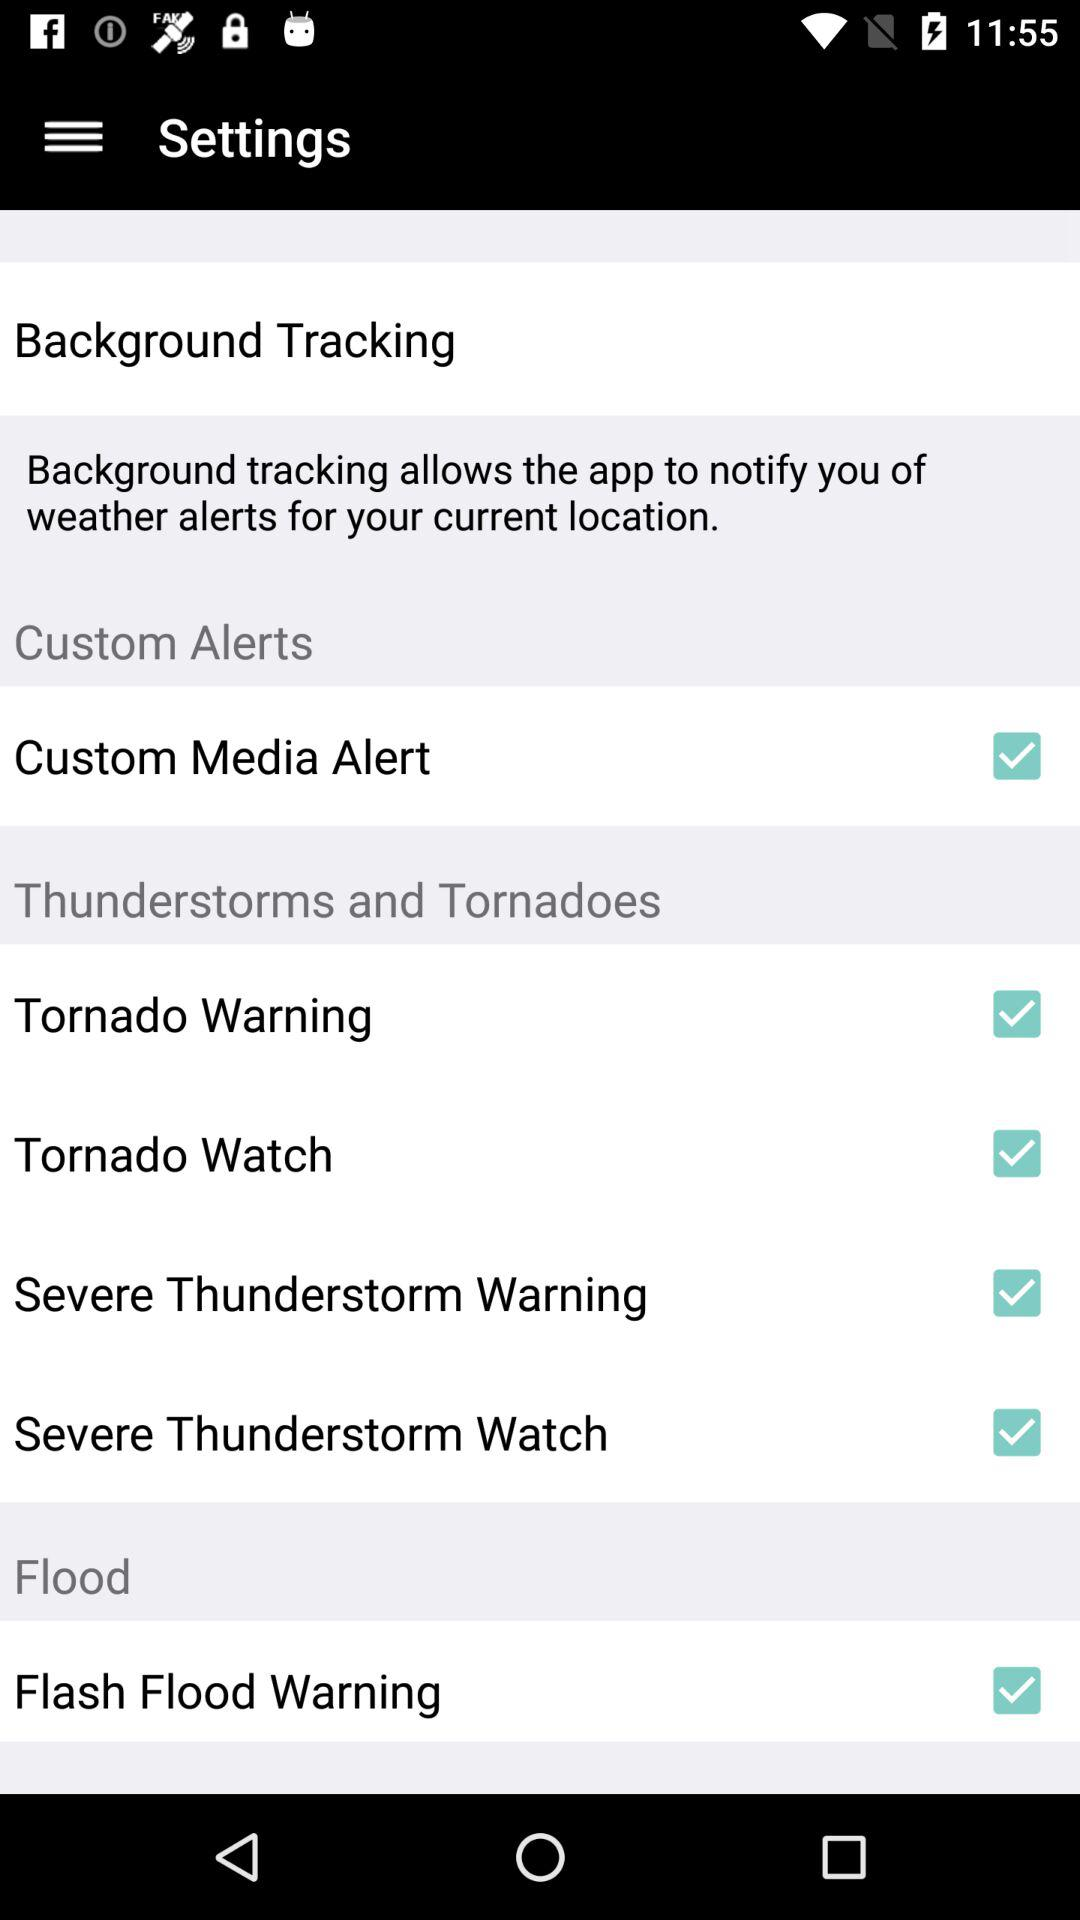What is the status of the "Flash Flood Warning"? The status is on. 